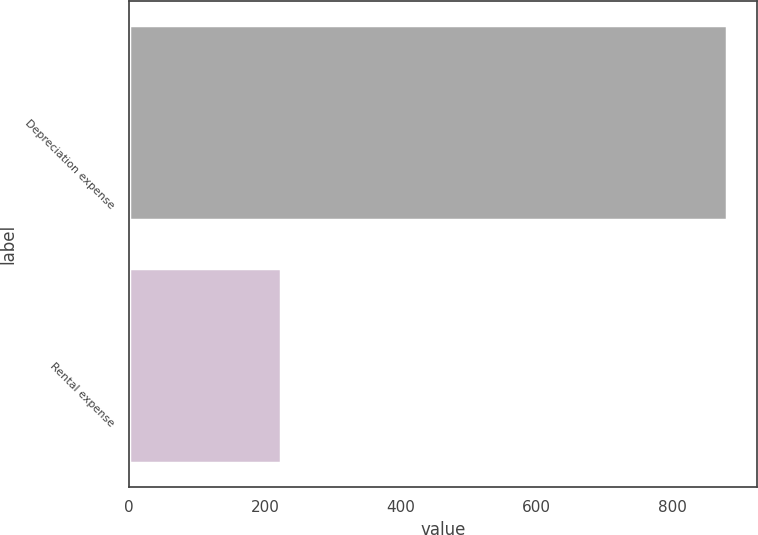<chart> <loc_0><loc_0><loc_500><loc_500><bar_chart><fcel>Depreciation expense<fcel>Rental expense<nl><fcel>879.6<fcel>223.2<nl></chart> 